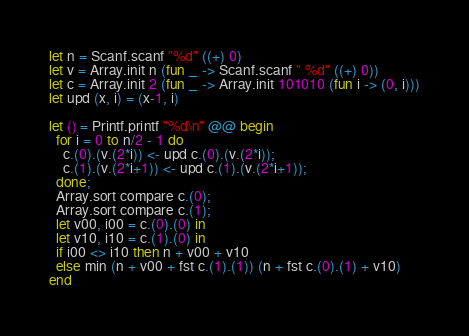Convert code to text. <code><loc_0><loc_0><loc_500><loc_500><_OCaml_>let n = Scanf.scanf "%d" ((+) 0)
let v = Array.init n (fun _ -> Scanf.scanf " %d" ((+) 0))
let c = Array.init 2 (fun _ -> Array.init 101010 (fun i -> (0, i)))
let upd (x, i) = (x-1, i)

let () = Printf.printf "%d\n" @@ begin
  for i = 0 to n/2 - 1 do
    c.(0).(v.(2*i)) <- upd c.(0).(v.(2*i));
    c.(1).(v.(2*i+1)) <- upd c.(1).(v.(2*i+1));
  done;
  Array.sort compare c.(0);
  Array.sort compare c.(1);
  let v00, i00 = c.(0).(0) in
  let v10, i10 = c.(1).(0) in
  if i00 <> i10 then n + v00 + v10
  else min (n + v00 + fst c.(1).(1)) (n + fst c.(0).(1) + v10)
end</code> 